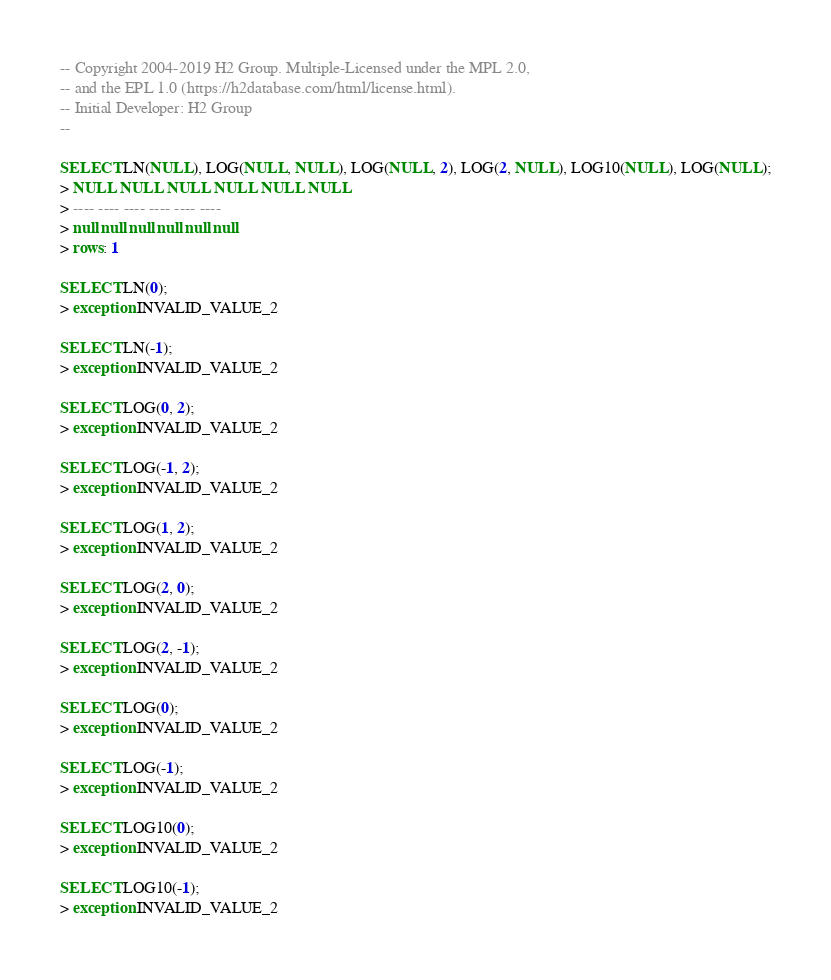<code> <loc_0><loc_0><loc_500><loc_500><_SQL_>-- Copyright 2004-2019 H2 Group. Multiple-Licensed under the MPL 2.0,
-- and the EPL 1.0 (https://h2database.com/html/license.html).
-- Initial Developer: H2 Group
--

SELECT LN(NULL), LOG(NULL, NULL), LOG(NULL, 2), LOG(2, NULL), LOG10(NULL), LOG(NULL);
> NULL NULL NULL NULL NULL NULL
> ---- ---- ---- ---- ---- ----
> null null null null null null
> rows: 1

SELECT LN(0);
> exception INVALID_VALUE_2

SELECT LN(-1);
> exception INVALID_VALUE_2

SELECT LOG(0, 2);
> exception INVALID_VALUE_2

SELECT LOG(-1, 2);
> exception INVALID_VALUE_2

SELECT LOG(1, 2);
> exception INVALID_VALUE_2

SELECT LOG(2, 0);
> exception INVALID_VALUE_2

SELECT LOG(2, -1);
> exception INVALID_VALUE_2

SELECT LOG(0);
> exception INVALID_VALUE_2

SELECT LOG(-1);
> exception INVALID_VALUE_2

SELECT LOG10(0);
> exception INVALID_VALUE_2

SELECT LOG10(-1);
> exception INVALID_VALUE_2
</code> 